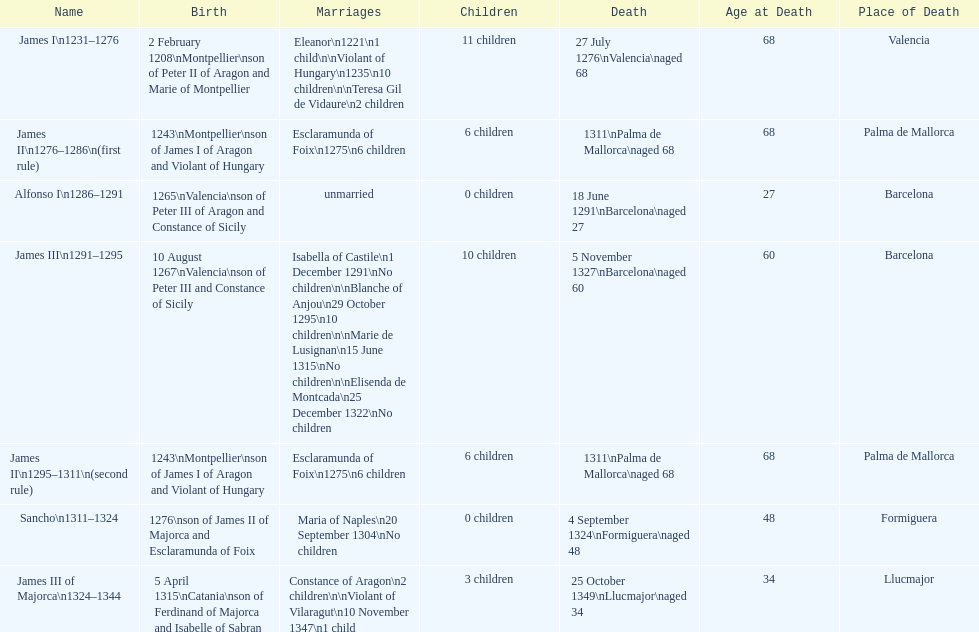What name is above james iii and below james ii? Alfonso I. 